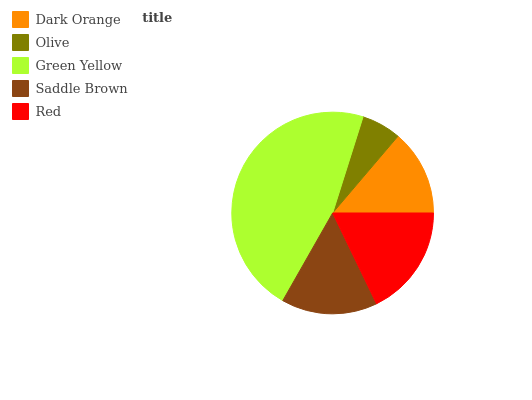Is Olive the minimum?
Answer yes or no. Yes. Is Green Yellow the maximum?
Answer yes or no. Yes. Is Green Yellow the minimum?
Answer yes or no. No. Is Olive the maximum?
Answer yes or no. No. Is Green Yellow greater than Olive?
Answer yes or no. Yes. Is Olive less than Green Yellow?
Answer yes or no. Yes. Is Olive greater than Green Yellow?
Answer yes or no. No. Is Green Yellow less than Olive?
Answer yes or no. No. Is Saddle Brown the high median?
Answer yes or no. Yes. Is Saddle Brown the low median?
Answer yes or no. Yes. Is Red the high median?
Answer yes or no. No. Is Dark Orange the low median?
Answer yes or no. No. 